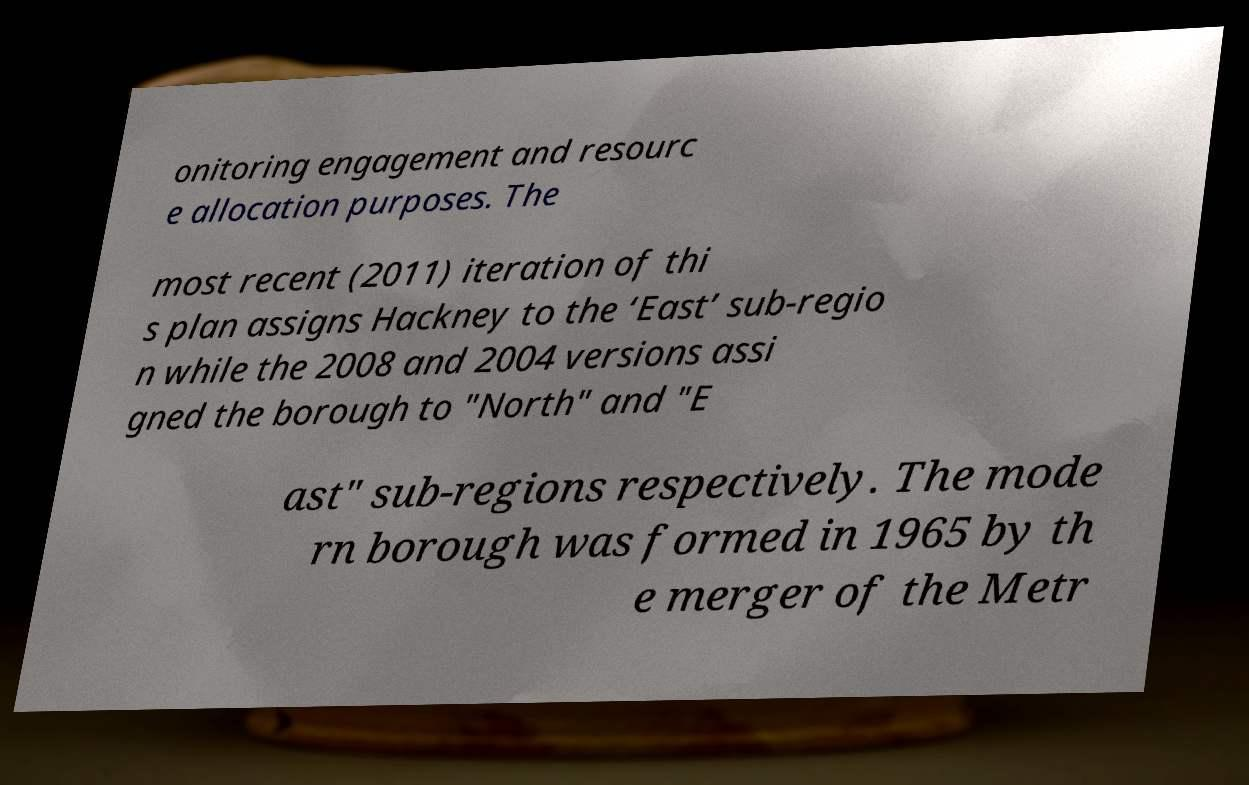Please read and relay the text visible in this image. What does it say? onitoring engagement and resourc e allocation purposes. The most recent (2011) iteration of thi s plan assigns Hackney to the ‘East’ sub-regio n while the 2008 and 2004 versions assi gned the borough to "North" and "E ast" sub-regions respectively. The mode rn borough was formed in 1965 by th e merger of the Metr 